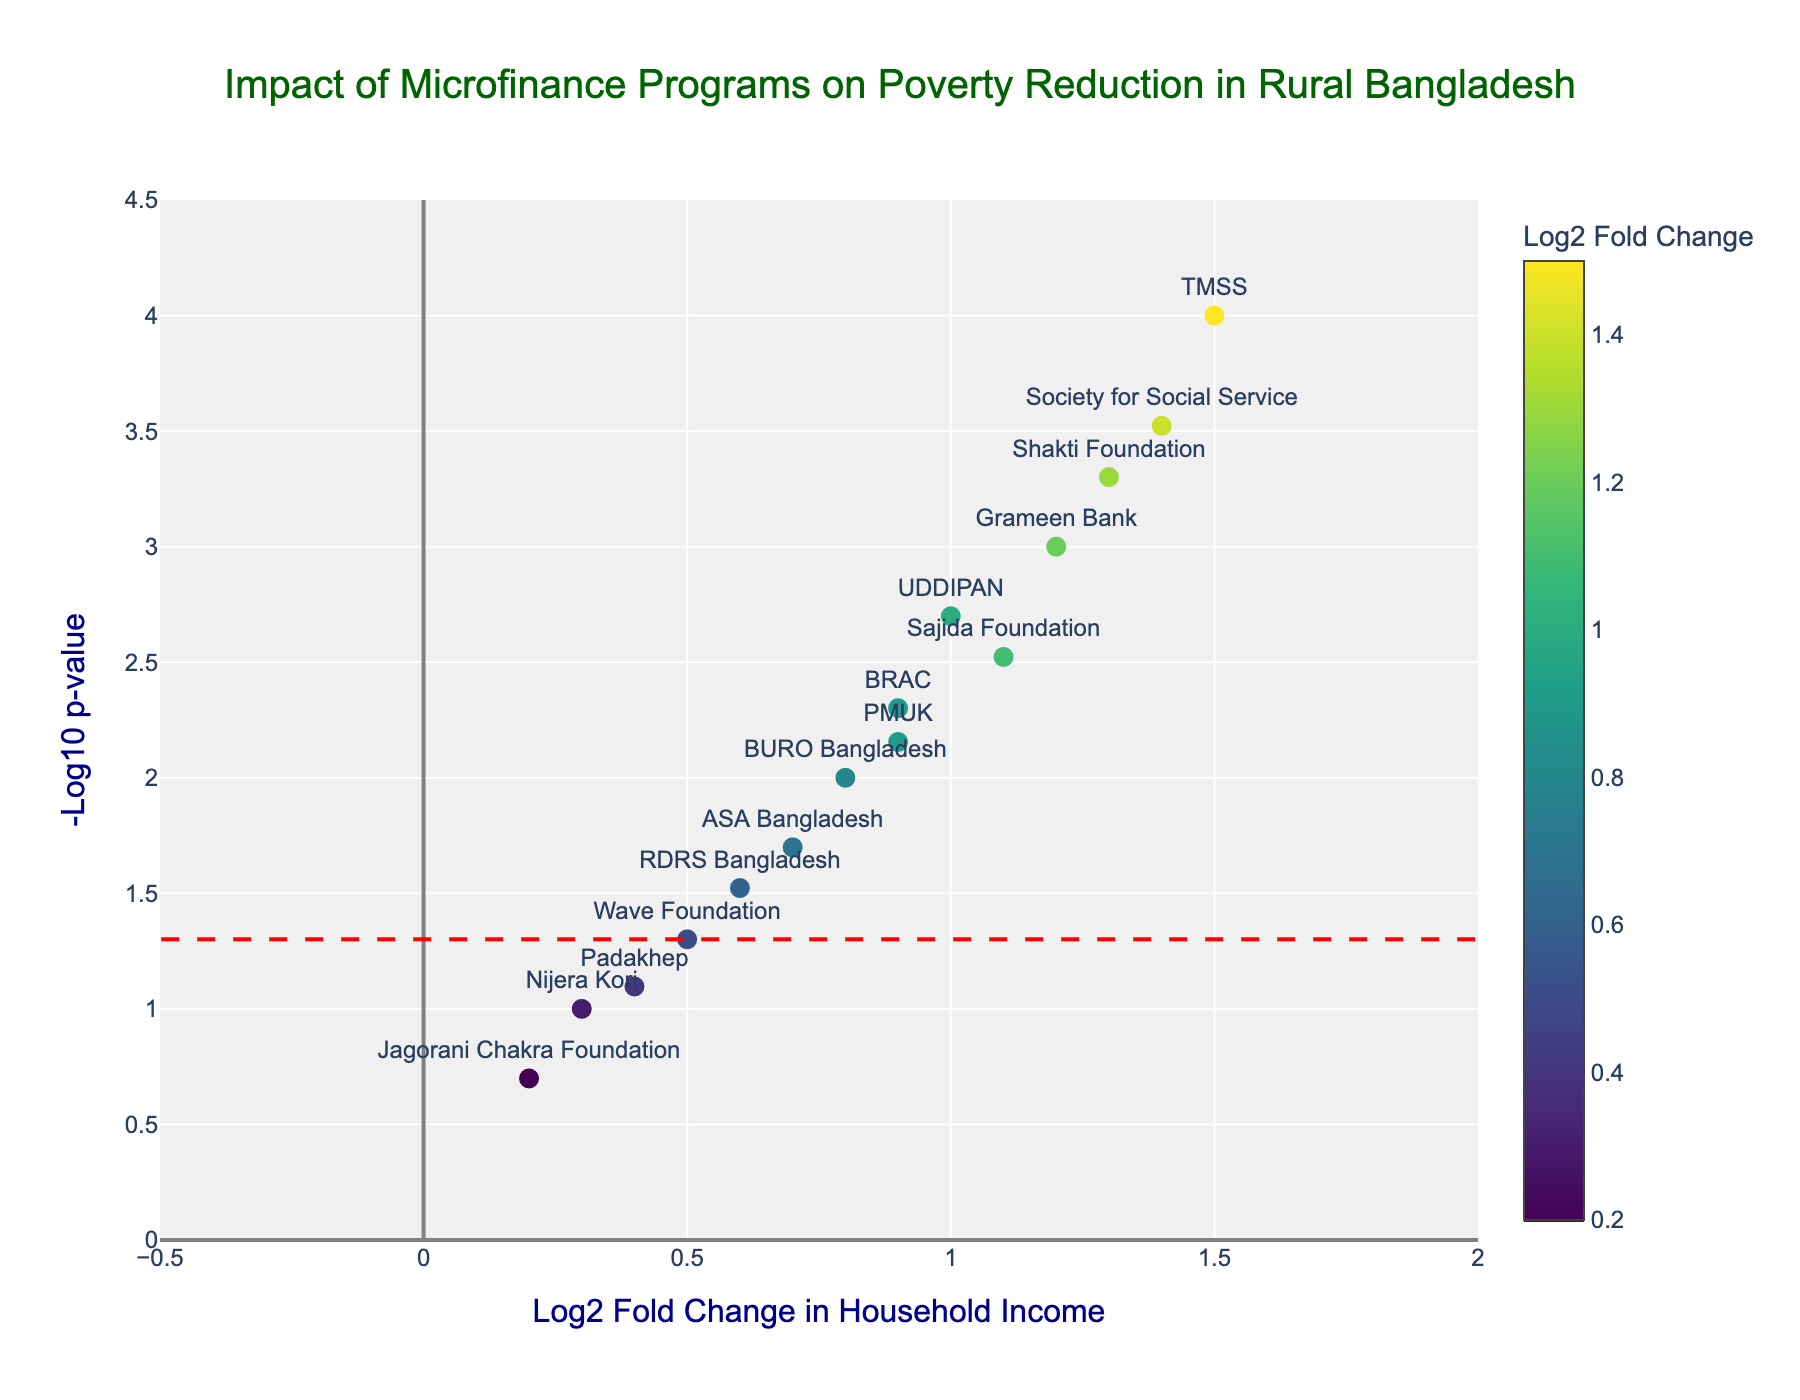How many microfinance programs are represented in the plot? By counting the labels of each data point plotted, we find there are 15 microfinance programs represented.
Answer: 15 Which microfinance program has the highest log2 fold change in household income? Among the data points, TMSS has the highest log2 fold change at 1.5.
Answer: TMSS What is the significance threshold line’s -log10 p-value? The threshold line is placed at -log10(0.05), which calculates to approximately 1.30.
Answer: 1.30 How many programs have a p-value below 0.05? By counting the programs with -log10(p-value) greater than 1.30, we find there are 11 programs.
Answer: 11 Which program has the lowest p-value and what is its -log10 p-value? TMSS has the lowest p-value at 0.0001, converting to -log10(0.0001) = 4.
Answer: TMSS, 4 Which microfinance programs have both log2 fold change greater than 1 and a p-value less than 0.05? These programs are Grameen Bank, TMSS, Sajida Foundation, Shakti Foundation, UDDIPAN, and Society for Social Service.
Answer: Grameen Bank, TMSS, Sajida Foundation, Shakti Foundation, UDDIPAN, Society for Social Service What is the average log2 fold change for all programs represented? Summing all log2 fold changes (1.2 + 0.9 + 0.7 + 1.5 + 0.3 + 1.1 + 0.6 + 0.8 + 1.3 + 0.4 + 0.5 + 1.0 + 0.2 + 0.9 + 1.4) = 12.8 and dividing by 15 programs, the average log2 fold change is approximately 0.85.
Answer: 0.85 Which program has the lowest log2 fold change and what is its value? Jagorani Chakra Foundation has the lowest log2 fold change at 0.2.
Answer: Jagorani Chakra Foundation, 0.2 Between Grameen Bank and BRAC, which has a higher statistical significance in changing household income, and what are their p-values? Grameen Bank has a lower p-value of 0.001 compared to BRAC's p-value of 0.005, indicating higher statistical significance.
Answer: Grameen Bank, 0.001; BRAC, 0.005 